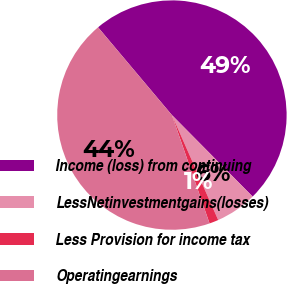<chart> <loc_0><loc_0><loc_500><loc_500><pie_chart><fcel>Income (loss) from continuing<fcel>LessNetinvestmentgains(losses)<fcel>Less Provision for income tax<fcel>Operatingearnings<nl><fcel>48.71%<fcel>5.81%<fcel>1.29%<fcel>44.19%<nl></chart> 